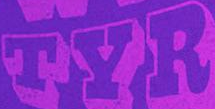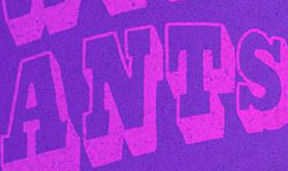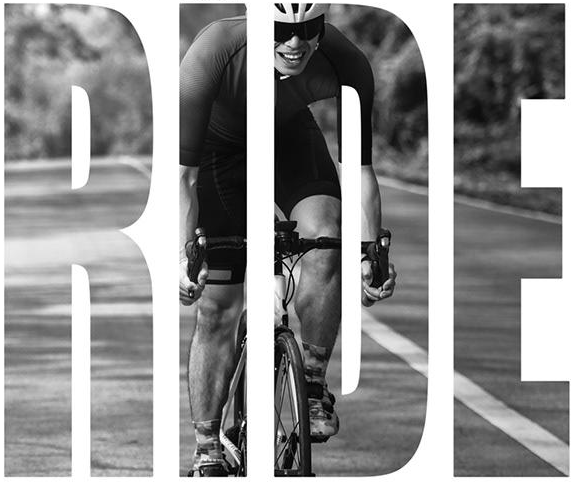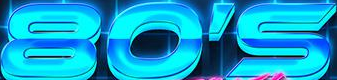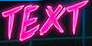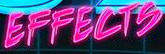What words can you see in these images in sequence, separated by a semicolon? TYR; ANTS; RIDE; 80'S; TEXT; EFFECTS 